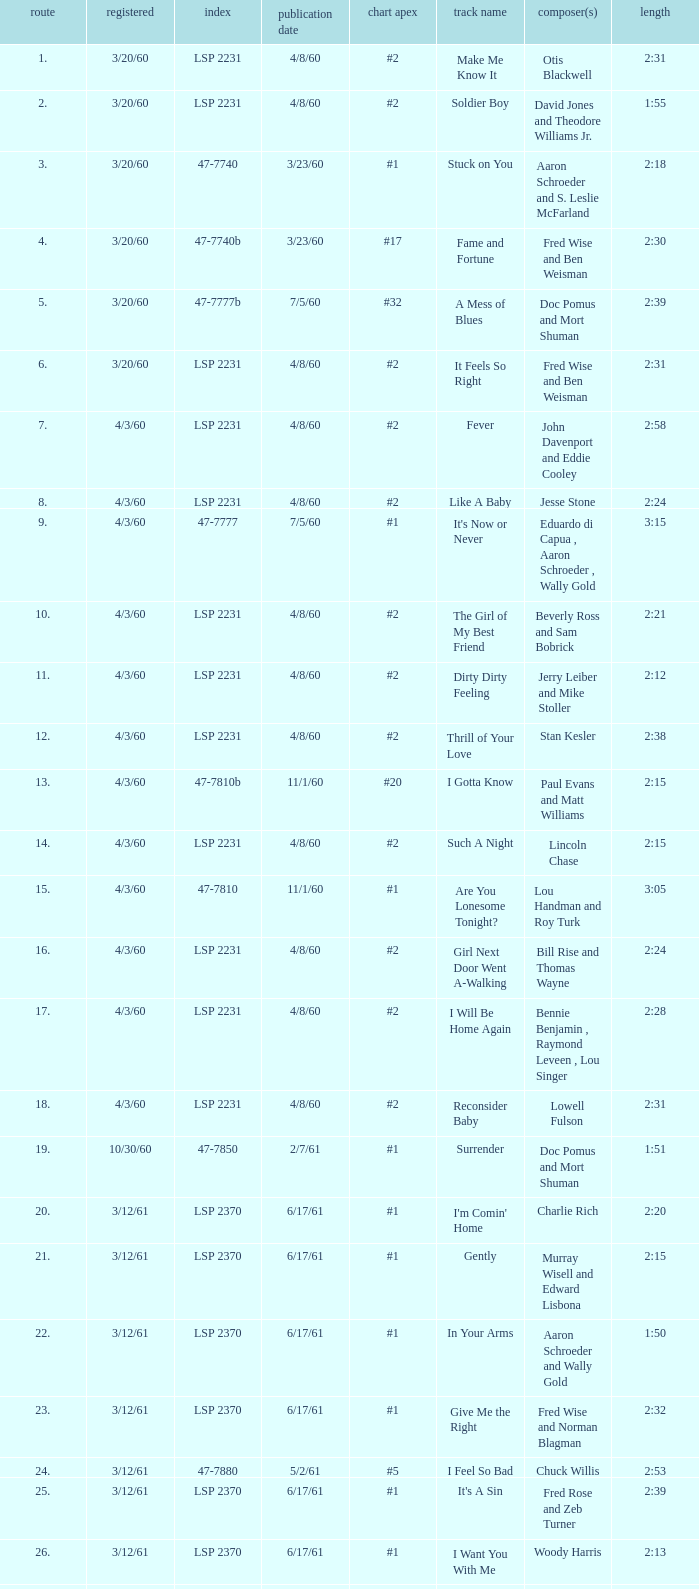On songs with track numbers smaller than number 17 and catalogues of LSP 2231, who are the writer(s)? Otis Blackwell, David Jones and Theodore Williams Jr., Fred Wise and Ben Weisman, John Davenport and Eddie Cooley, Jesse Stone, Beverly Ross and Sam Bobrick, Jerry Leiber and Mike Stoller, Stan Kesler, Lincoln Chase, Bill Rise and Thomas Wayne. 